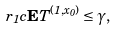<formula> <loc_0><loc_0><loc_500><loc_500>r _ { 1 } c { \mathbf E } T ^ { ( 1 , x _ { 0 } ) } \leq \gamma ,</formula> 